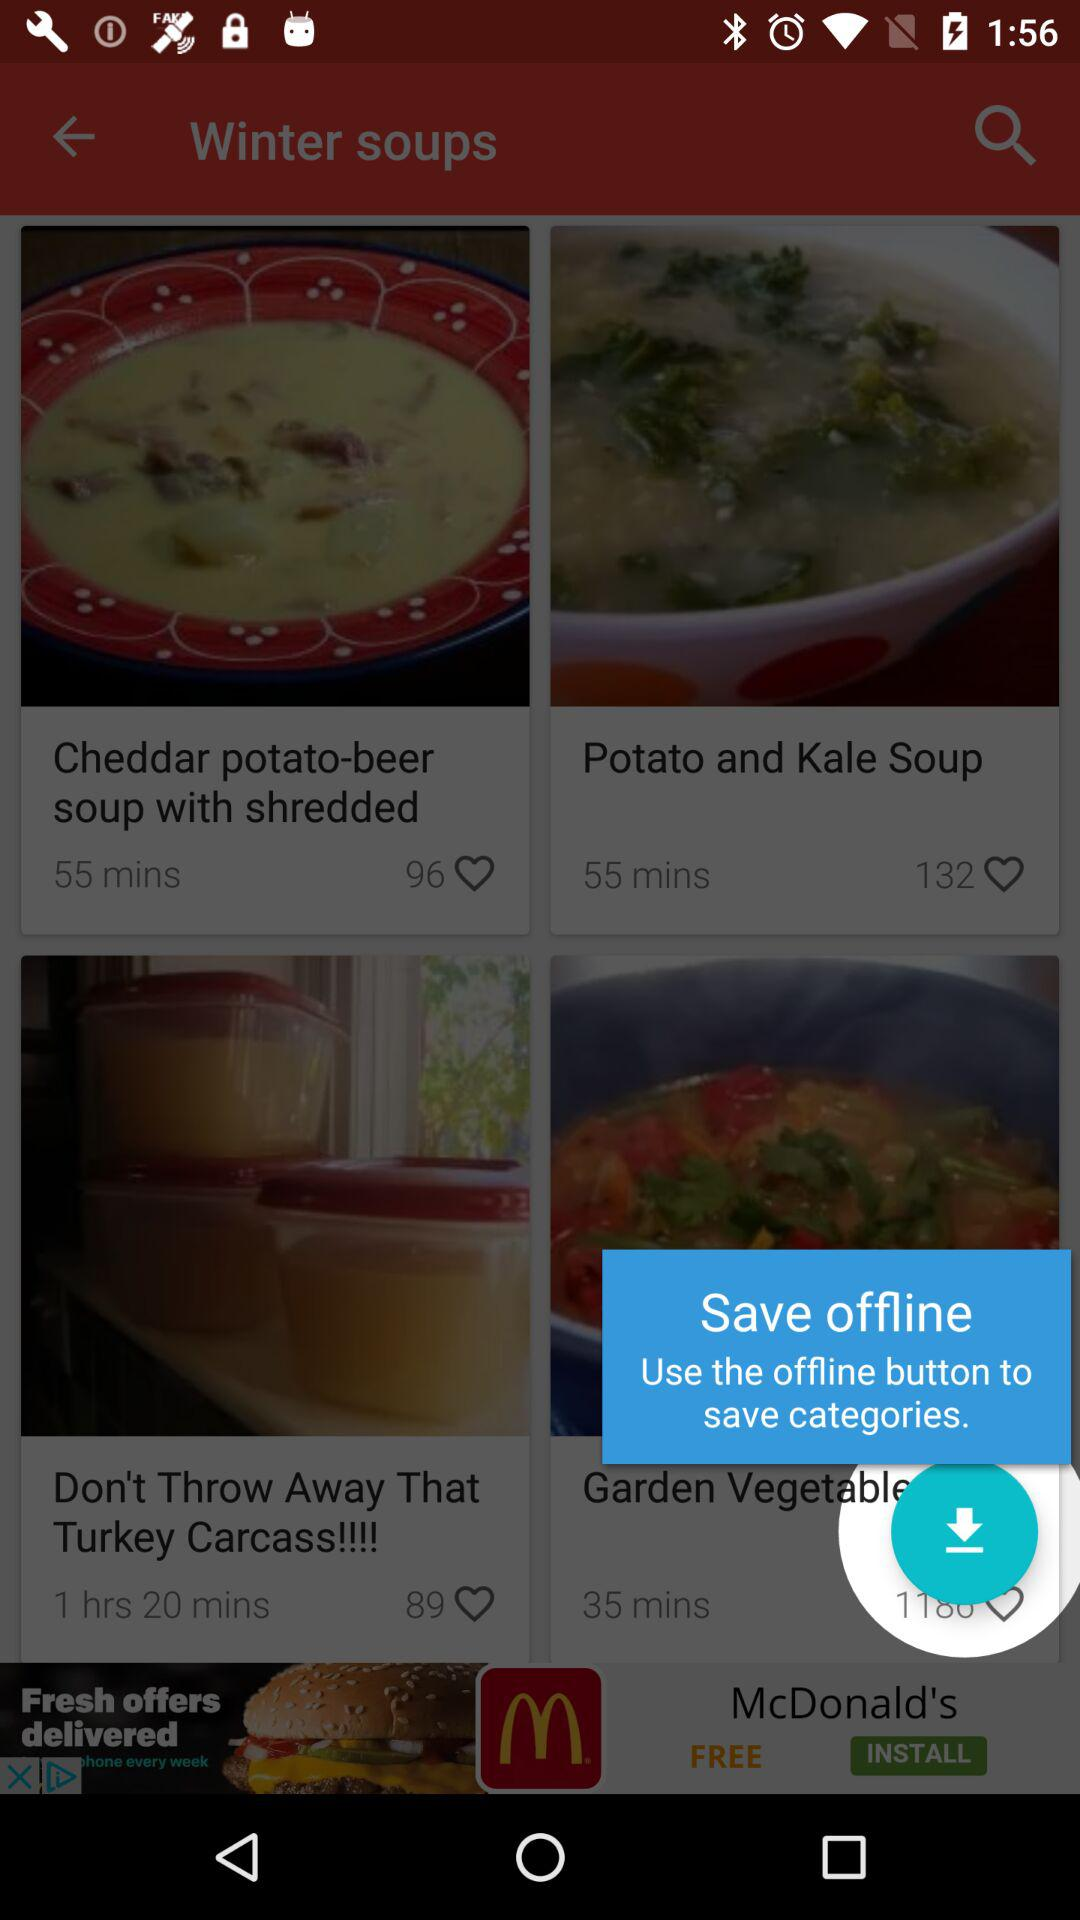How many likes are for the potato and kale soup? For the potato and kale soup, there are 132 likes. 